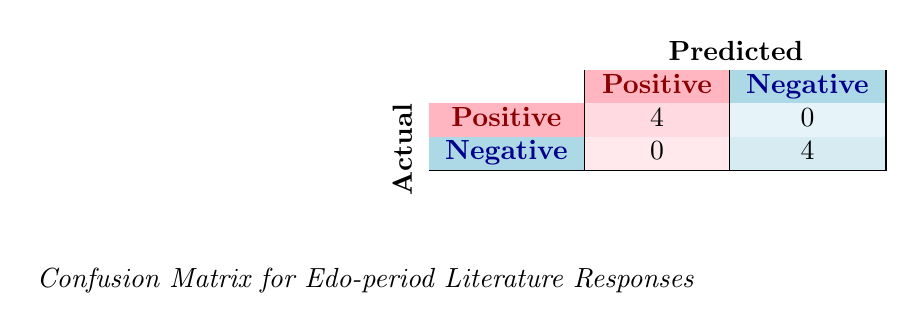What is the total number of audience responses categorized as positive? The table indicates there are 4 responses within the positive category. This is observed under the row labeled "Positive" and the corresponding column that lists the values, specifically showing "4".
Answer: 4 How many audience members provided negative responses? The total for negative responses is also listed in the "Negative" category. By referring to that column, we find there are 4 audience members who provided negative feedback as shown by the value "4" in that cell.
Answer: 4 Is there any audience member who categorized their response as both positive and negative? Examining the table, there are no overlapping values in the positive and negative columns. Each category distinctly shows the audience members classified without any intermingling. Thus, the answer is no.
Answer: No What is the sum of positive and negative responses in total? The positive responses total 4, and the negative responses also total 4. When summed up, the total audience responses are calculated as 4 (positive) + 4 (negative) = 8.
Answer: 8 How many audience members had a positive response about The Tale of Genji? Within the table, we specifically look under the positive responses and see that there is 1 matching entry for The Tale of Genji under the positive responses by Emily Johnson.
Answer: 1 What is the difference in the number of positive and negative responses? The positive responses amount to 4, while the negative responses also amount to 4. Therefore, the difference is calculated as 4 (positive) - 4 (negative) = 0, indicating an equal number of responses in both categories.
Answer: 0 Did any audience member express a positive response for The Crazy Cloud Shelf? Looking at the negative responses, Oliver Martinez expressed a negative response regarding The Crazy Cloud Shelf. No audience member listed a positive response for this work, therefore the answer is no.
Answer: No How many works had only positive feedback? The works listed with positive feedback are The Tale of Genji, The Man Who Touched His Own Heart, Yoshitsune and the Thousand Cherry Trees, and The Azuma Chronicles. There are 4 different works associated with positive responses in total.
Answer: 4 How many unique works received audience responses? Four positive responses are noted with The Tale of Genji, The Man Who Touched His Own Heart, Yoshitsune and the Thousand Cherry Trees, and The Azuma Chronicles, and four negative responses for Kusamakura, The Tale of Heike, The Book of Five Rings, and The Crazy Cloud Shelf. Thus, the total unique works equate to 8.
Answer: 8 